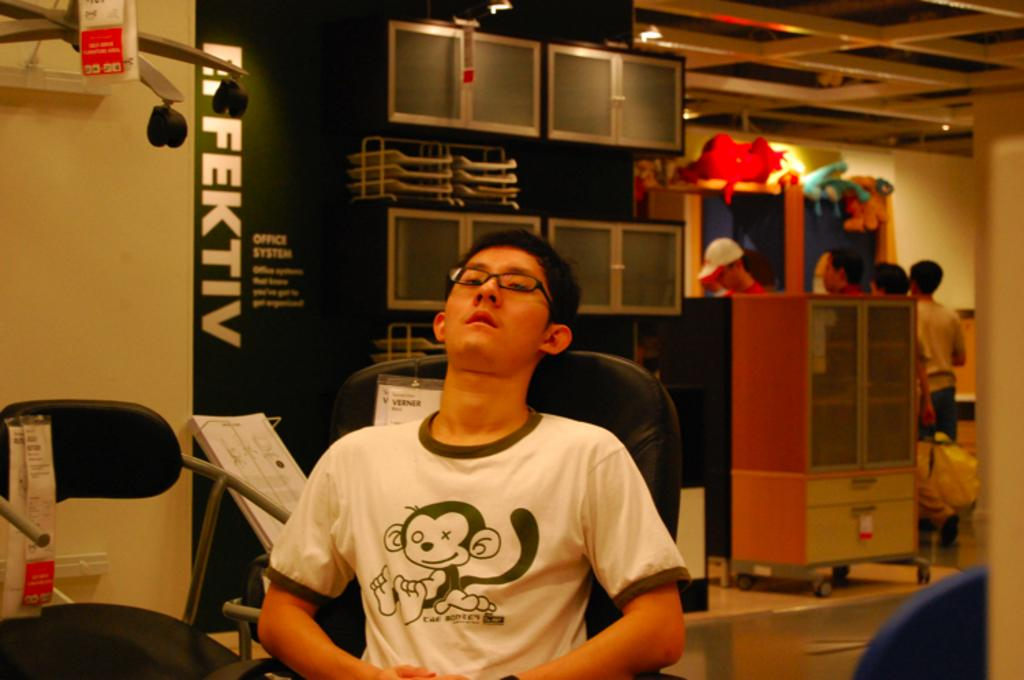What type of structure can be seen in the image? There is a wall in the image. What is hanging on the wall in the image? There is a banner in the image. Are there any people present in the image? Yes, there are people standing in the image. What is the position of the man in the image? A man is sitting on a chair in the image. How many gloves are being used by the people in the image? There is no mention of gloves in the image, so it cannot be determined if any are being used. 